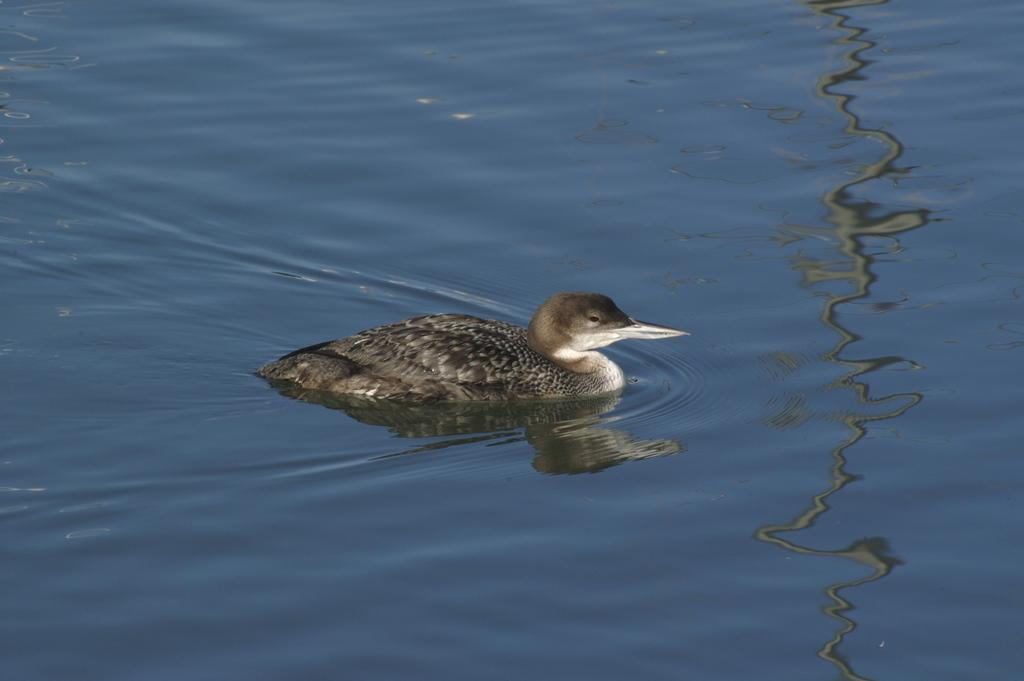What type of animal is in the image? There is a bird in the image. Where is the bird located in the image? The bird is in the water. What type of oatmeal is the bird eating in the image? There is no oatmeal present in the image; the bird is in the water. What is the bird using to carry the pail in the image? There is no pail present in the image, and the bird is not carrying anything. 